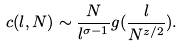Convert formula to latex. <formula><loc_0><loc_0><loc_500><loc_500>c ( l , N ) \sim \frac { N } { l ^ { \sigma - 1 } } g ( \frac { l } { N ^ { z / 2 } } ) .</formula> 